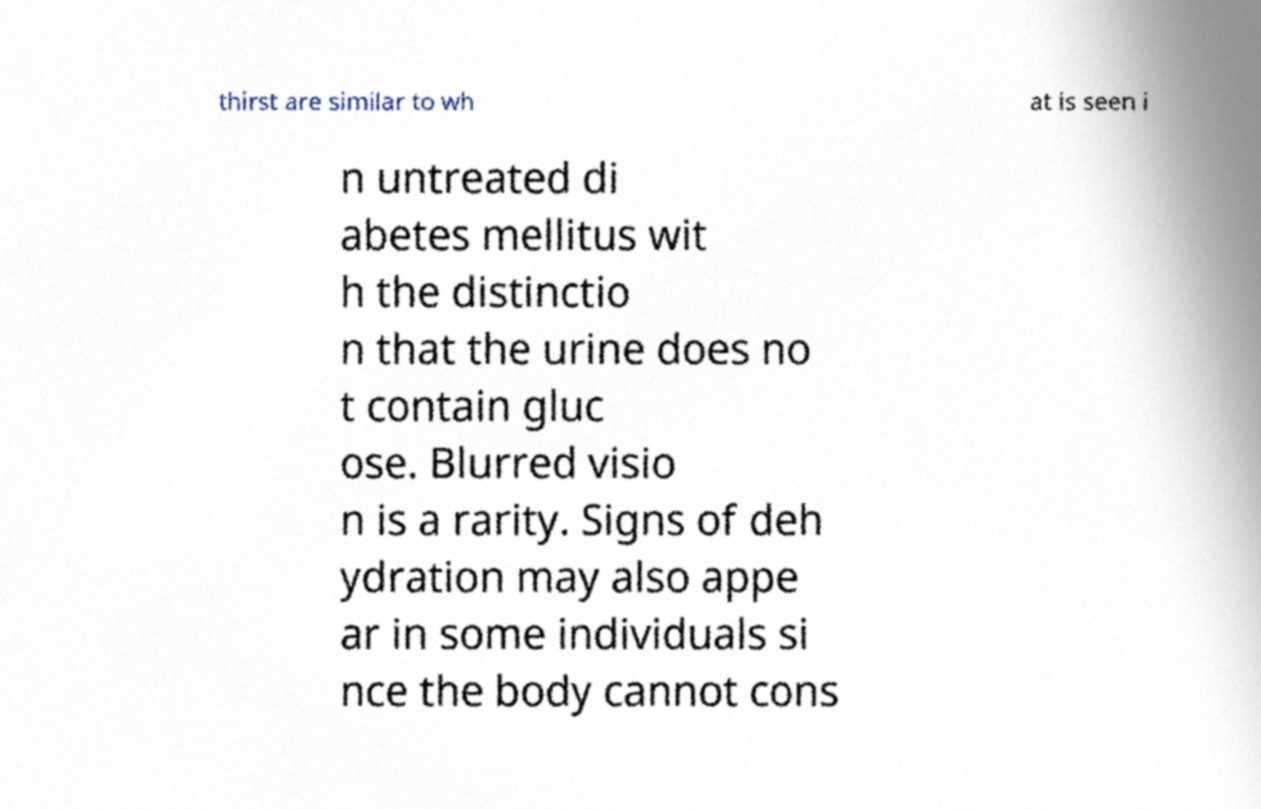Can you read and provide the text displayed in the image?This photo seems to have some interesting text. Can you extract and type it out for me? thirst are similar to wh at is seen i n untreated di abetes mellitus wit h the distinctio n that the urine does no t contain gluc ose. Blurred visio n is a rarity. Signs of deh ydration may also appe ar in some individuals si nce the body cannot cons 